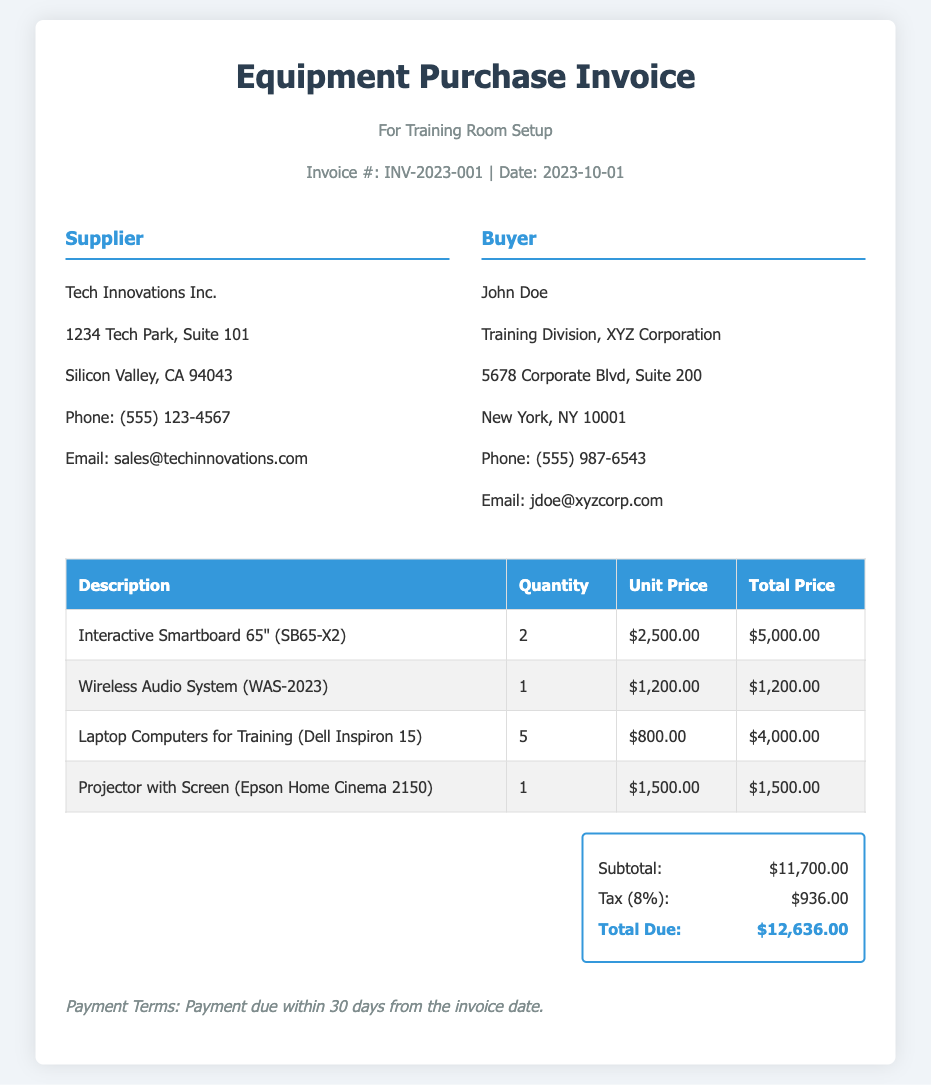What is the invoice number? The invoice number is listed in the header of the document, which is INV-2023-001.
Answer: INV-2023-001 Who is the supplier? The supplier's name is mentioned in the invoice, shown as Tech Innovations Inc.
Answer: Tech Innovations Inc What is the total due amount? The total due amount is summarized at the bottom of the invoice as $12,636.00.
Answer: $12,636.00 How many Laptop Computers were purchased? The quantity of Laptop Computers for Training is provided in the table, which states 5 units were purchased.
Answer: 5 What is the tax percentage applied? The tax percentage is mentioned in the summary section as 8%.
Answer: 8% What is the quantity of Interactive Smartboard 65"? The quantity for Interactive Smartboard 65" is indicated in the table, which shows 2 units.
Answer: 2 What is the price of the Wireless Audio System? The unit price for the Wireless Audio System is listed in the table as $1,200.00.
Answer: $1,200.00 What are the payment terms specified? The payment terms are noted at the bottom of the invoice, stating payment due within 30 days from the invoice date.
Answer: 30 days What is the subtotal amount before tax? The subtotal amount is shown in the summary section as $11,700.00.
Answer: $11,700.00 